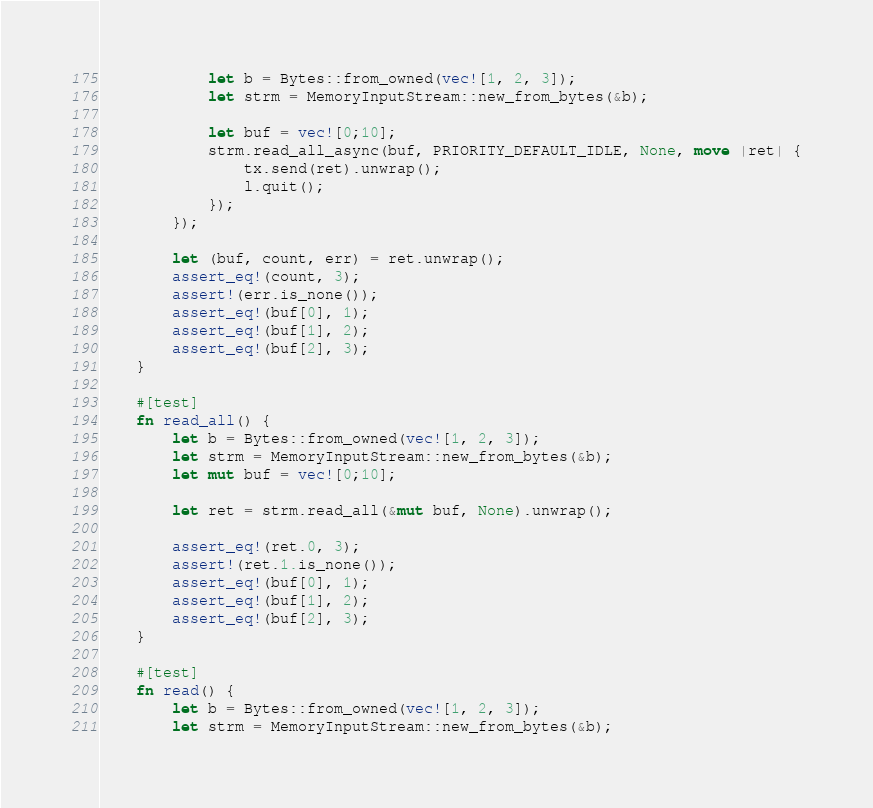Convert code to text. <code><loc_0><loc_0><loc_500><loc_500><_Rust_>            let b = Bytes::from_owned(vec![1, 2, 3]);
            let strm = MemoryInputStream::new_from_bytes(&b);

            let buf = vec![0;10];
            strm.read_all_async(buf, PRIORITY_DEFAULT_IDLE, None, move |ret| {
                tx.send(ret).unwrap();
                l.quit();
            });
        });

        let (buf, count, err) = ret.unwrap();
        assert_eq!(count, 3);
        assert!(err.is_none());
        assert_eq!(buf[0], 1);
        assert_eq!(buf[1], 2);
        assert_eq!(buf[2], 3);
    }

    #[test]
    fn read_all() {
        let b = Bytes::from_owned(vec![1, 2, 3]);
        let strm = MemoryInputStream::new_from_bytes(&b);
        let mut buf = vec![0;10];

        let ret = strm.read_all(&mut buf, None).unwrap();

        assert_eq!(ret.0, 3);
        assert!(ret.1.is_none());
        assert_eq!(buf[0], 1);
        assert_eq!(buf[1], 2);
        assert_eq!(buf[2], 3);
    }

    #[test]
    fn read() {
        let b = Bytes::from_owned(vec![1, 2, 3]);
        let strm = MemoryInputStream::new_from_bytes(&b);</code> 